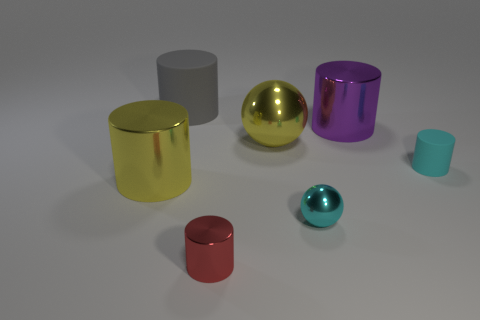Is there any other thing that is the same color as the small shiny cylinder?
Give a very brief answer. No. There is a small cyan object that is to the left of the tiny cylinder that is to the right of the purple thing; are there any big gray things to the right of it?
Keep it short and to the point. No. What is the color of the big metal ball?
Give a very brief answer. Yellow. There is a tiny red cylinder; are there any purple shiny objects in front of it?
Your answer should be very brief. No. There is a large purple metal thing; is its shape the same as the big gray thing that is behind the red shiny object?
Your response must be concise. Yes. How many other objects are there of the same material as the big ball?
Make the answer very short. 4. The tiny cylinder in front of the small cyan thing behind the large shiny cylinder that is to the left of the red object is what color?
Provide a succinct answer. Red. What is the shape of the big metal object that is in front of the large yellow shiny thing behind the cyan matte thing?
Offer a terse response. Cylinder. Is the number of small red things left of the red metal cylinder greater than the number of big yellow spheres?
Your response must be concise. No. Is the shape of the yellow thing to the left of the large matte cylinder the same as  the big purple object?
Your answer should be compact. Yes. 